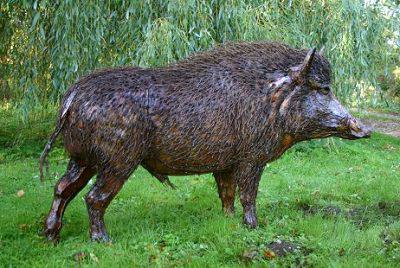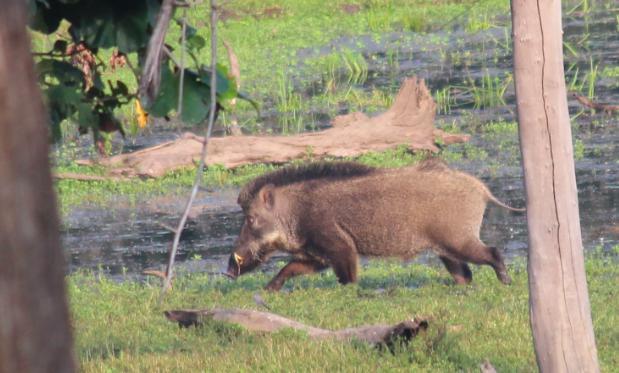The first image is the image on the left, the second image is the image on the right. Assess this claim about the two images: "A single warthog is facing to the right while standing on green grass in one of the images..". Correct or not? Answer yes or no. Yes. The first image is the image on the left, the second image is the image on the right. For the images displayed, is the sentence "There is a hog standing in the grass in the left image" factually correct? Answer yes or no. Yes. 